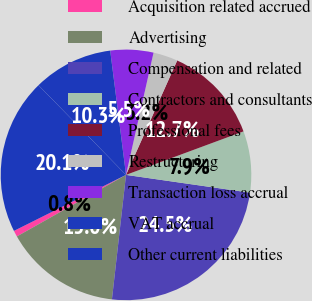Convert chart. <chart><loc_0><loc_0><loc_500><loc_500><pie_chart><fcel>Acquisition related accrued<fcel>Advertising<fcel>Compensation and related<fcel>Contractors and consultants<fcel>Professional fees<fcel>Restructuring<fcel>Transaction loss accrual<fcel>VAT accrual<fcel>Other current liabilities<nl><fcel>0.8%<fcel>15.03%<fcel>24.52%<fcel>7.91%<fcel>12.66%<fcel>3.17%<fcel>5.54%<fcel>10.29%<fcel>20.07%<nl></chart> 